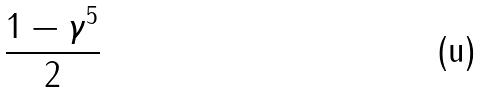<formula> <loc_0><loc_0><loc_500><loc_500>\frac { 1 - \gamma ^ { 5 } } { 2 }</formula> 